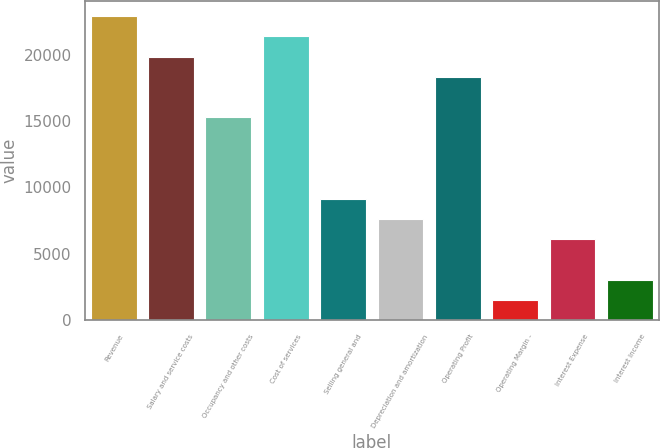Convert chart. <chart><loc_0><loc_0><loc_500><loc_500><bar_chart><fcel>Revenue<fcel>Salary and service costs<fcel>Occupancy and other costs<fcel>Cost of services<fcel>Selling general and<fcel>Depreciation and amortization<fcel>Operating Profit<fcel>Operating Margin -<fcel>Interest Expense<fcel>Interest Income<nl><fcel>22908.7<fcel>19854.6<fcel>15273.6<fcel>21381.6<fcel>9165.56<fcel>7638.55<fcel>18327.6<fcel>1530.51<fcel>6111.54<fcel>3057.52<nl></chart> 